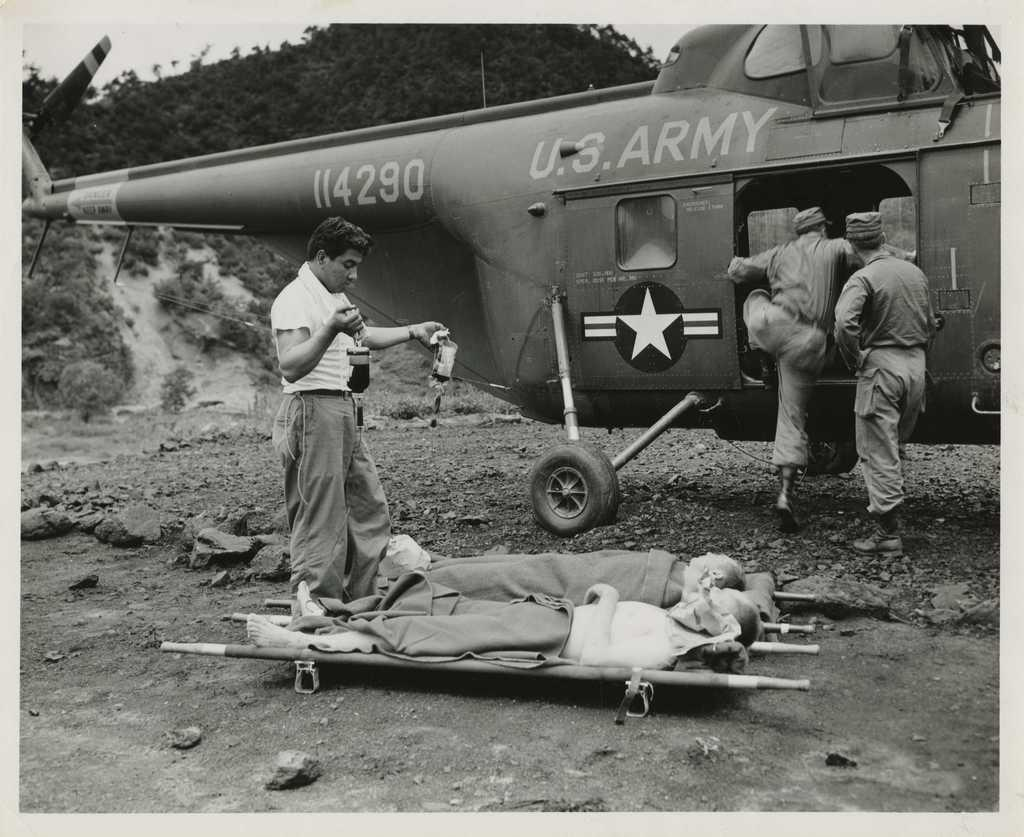<image>
Render a clear and concise summary of the photo. Men climb aboard a U.S. ARMY helicopter as other men lie on stretchers on the ground. 